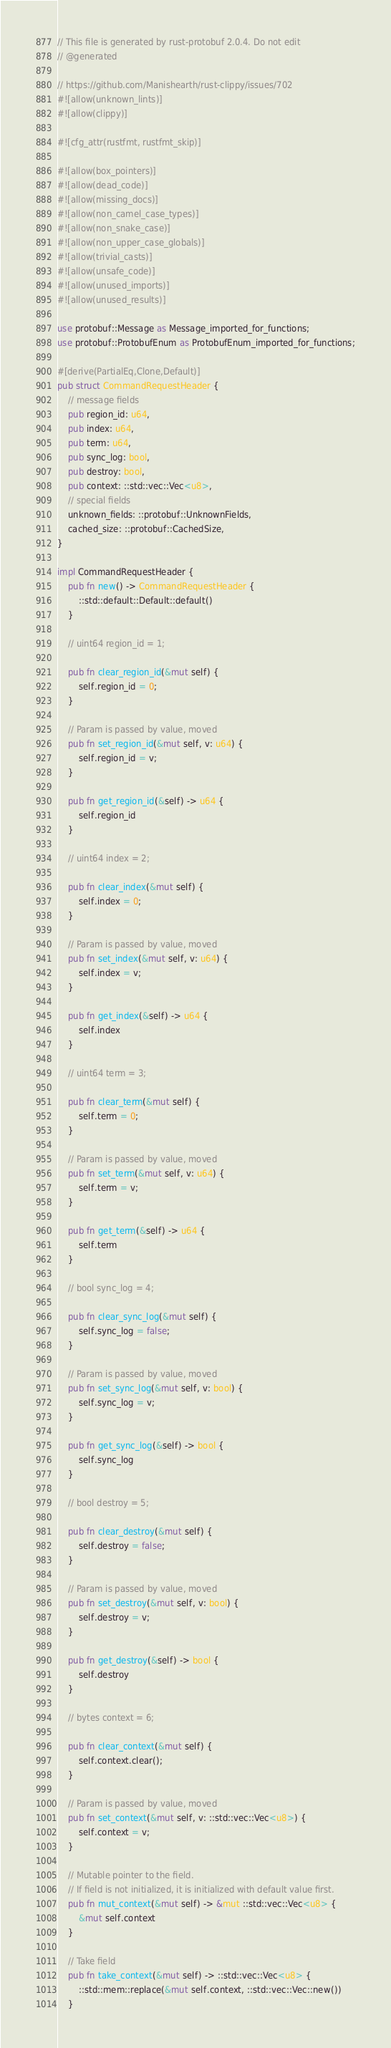<code> <loc_0><loc_0><loc_500><loc_500><_Rust_>// This file is generated by rust-protobuf 2.0.4. Do not edit
// @generated

// https://github.com/Manishearth/rust-clippy/issues/702
#![allow(unknown_lints)]
#![allow(clippy)]

#![cfg_attr(rustfmt, rustfmt_skip)]

#![allow(box_pointers)]
#![allow(dead_code)]
#![allow(missing_docs)]
#![allow(non_camel_case_types)]
#![allow(non_snake_case)]
#![allow(non_upper_case_globals)]
#![allow(trivial_casts)]
#![allow(unsafe_code)]
#![allow(unused_imports)]
#![allow(unused_results)]

use protobuf::Message as Message_imported_for_functions;
use protobuf::ProtobufEnum as ProtobufEnum_imported_for_functions;

#[derive(PartialEq,Clone,Default)]
pub struct CommandRequestHeader {
    // message fields
    pub region_id: u64,
    pub index: u64,
    pub term: u64,
    pub sync_log: bool,
    pub destroy: bool,
    pub context: ::std::vec::Vec<u8>,
    // special fields
    unknown_fields: ::protobuf::UnknownFields,
    cached_size: ::protobuf::CachedSize,
}

impl CommandRequestHeader {
    pub fn new() -> CommandRequestHeader {
        ::std::default::Default::default()
    }

    // uint64 region_id = 1;

    pub fn clear_region_id(&mut self) {
        self.region_id = 0;
    }

    // Param is passed by value, moved
    pub fn set_region_id(&mut self, v: u64) {
        self.region_id = v;
    }

    pub fn get_region_id(&self) -> u64 {
        self.region_id
    }

    // uint64 index = 2;

    pub fn clear_index(&mut self) {
        self.index = 0;
    }

    // Param is passed by value, moved
    pub fn set_index(&mut self, v: u64) {
        self.index = v;
    }

    pub fn get_index(&self) -> u64 {
        self.index
    }

    // uint64 term = 3;

    pub fn clear_term(&mut self) {
        self.term = 0;
    }

    // Param is passed by value, moved
    pub fn set_term(&mut self, v: u64) {
        self.term = v;
    }

    pub fn get_term(&self) -> u64 {
        self.term
    }

    // bool sync_log = 4;

    pub fn clear_sync_log(&mut self) {
        self.sync_log = false;
    }

    // Param is passed by value, moved
    pub fn set_sync_log(&mut self, v: bool) {
        self.sync_log = v;
    }

    pub fn get_sync_log(&self) -> bool {
        self.sync_log
    }

    // bool destroy = 5;

    pub fn clear_destroy(&mut self) {
        self.destroy = false;
    }

    // Param is passed by value, moved
    pub fn set_destroy(&mut self, v: bool) {
        self.destroy = v;
    }

    pub fn get_destroy(&self) -> bool {
        self.destroy
    }

    // bytes context = 6;

    pub fn clear_context(&mut self) {
        self.context.clear();
    }

    // Param is passed by value, moved
    pub fn set_context(&mut self, v: ::std::vec::Vec<u8>) {
        self.context = v;
    }

    // Mutable pointer to the field.
    // If field is not initialized, it is initialized with default value first.
    pub fn mut_context(&mut self) -> &mut ::std::vec::Vec<u8> {
        &mut self.context
    }

    // Take field
    pub fn take_context(&mut self) -> ::std::vec::Vec<u8> {
        ::std::mem::replace(&mut self.context, ::std::vec::Vec::new())
    }
</code> 